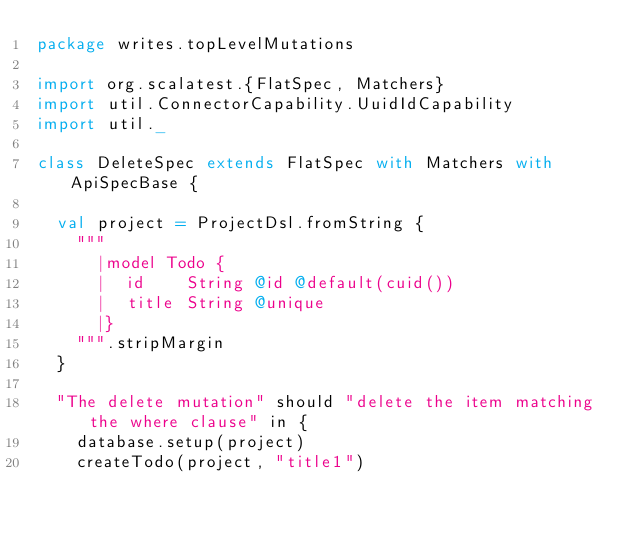<code> <loc_0><loc_0><loc_500><loc_500><_Scala_>package writes.topLevelMutations

import org.scalatest.{FlatSpec, Matchers}
import util.ConnectorCapability.UuidIdCapability
import util._

class DeleteSpec extends FlatSpec with Matchers with ApiSpecBase {

  val project = ProjectDsl.fromString {
    """
      |model Todo {
      |  id    String @id @default(cuid())
      |  title String @unique
      |}
    """.stripMargin
  }

  "The delete mutation" should "delete the item matching the where clause" in {
    database.setup(project)
    createTodo(project, "title1")</code> 